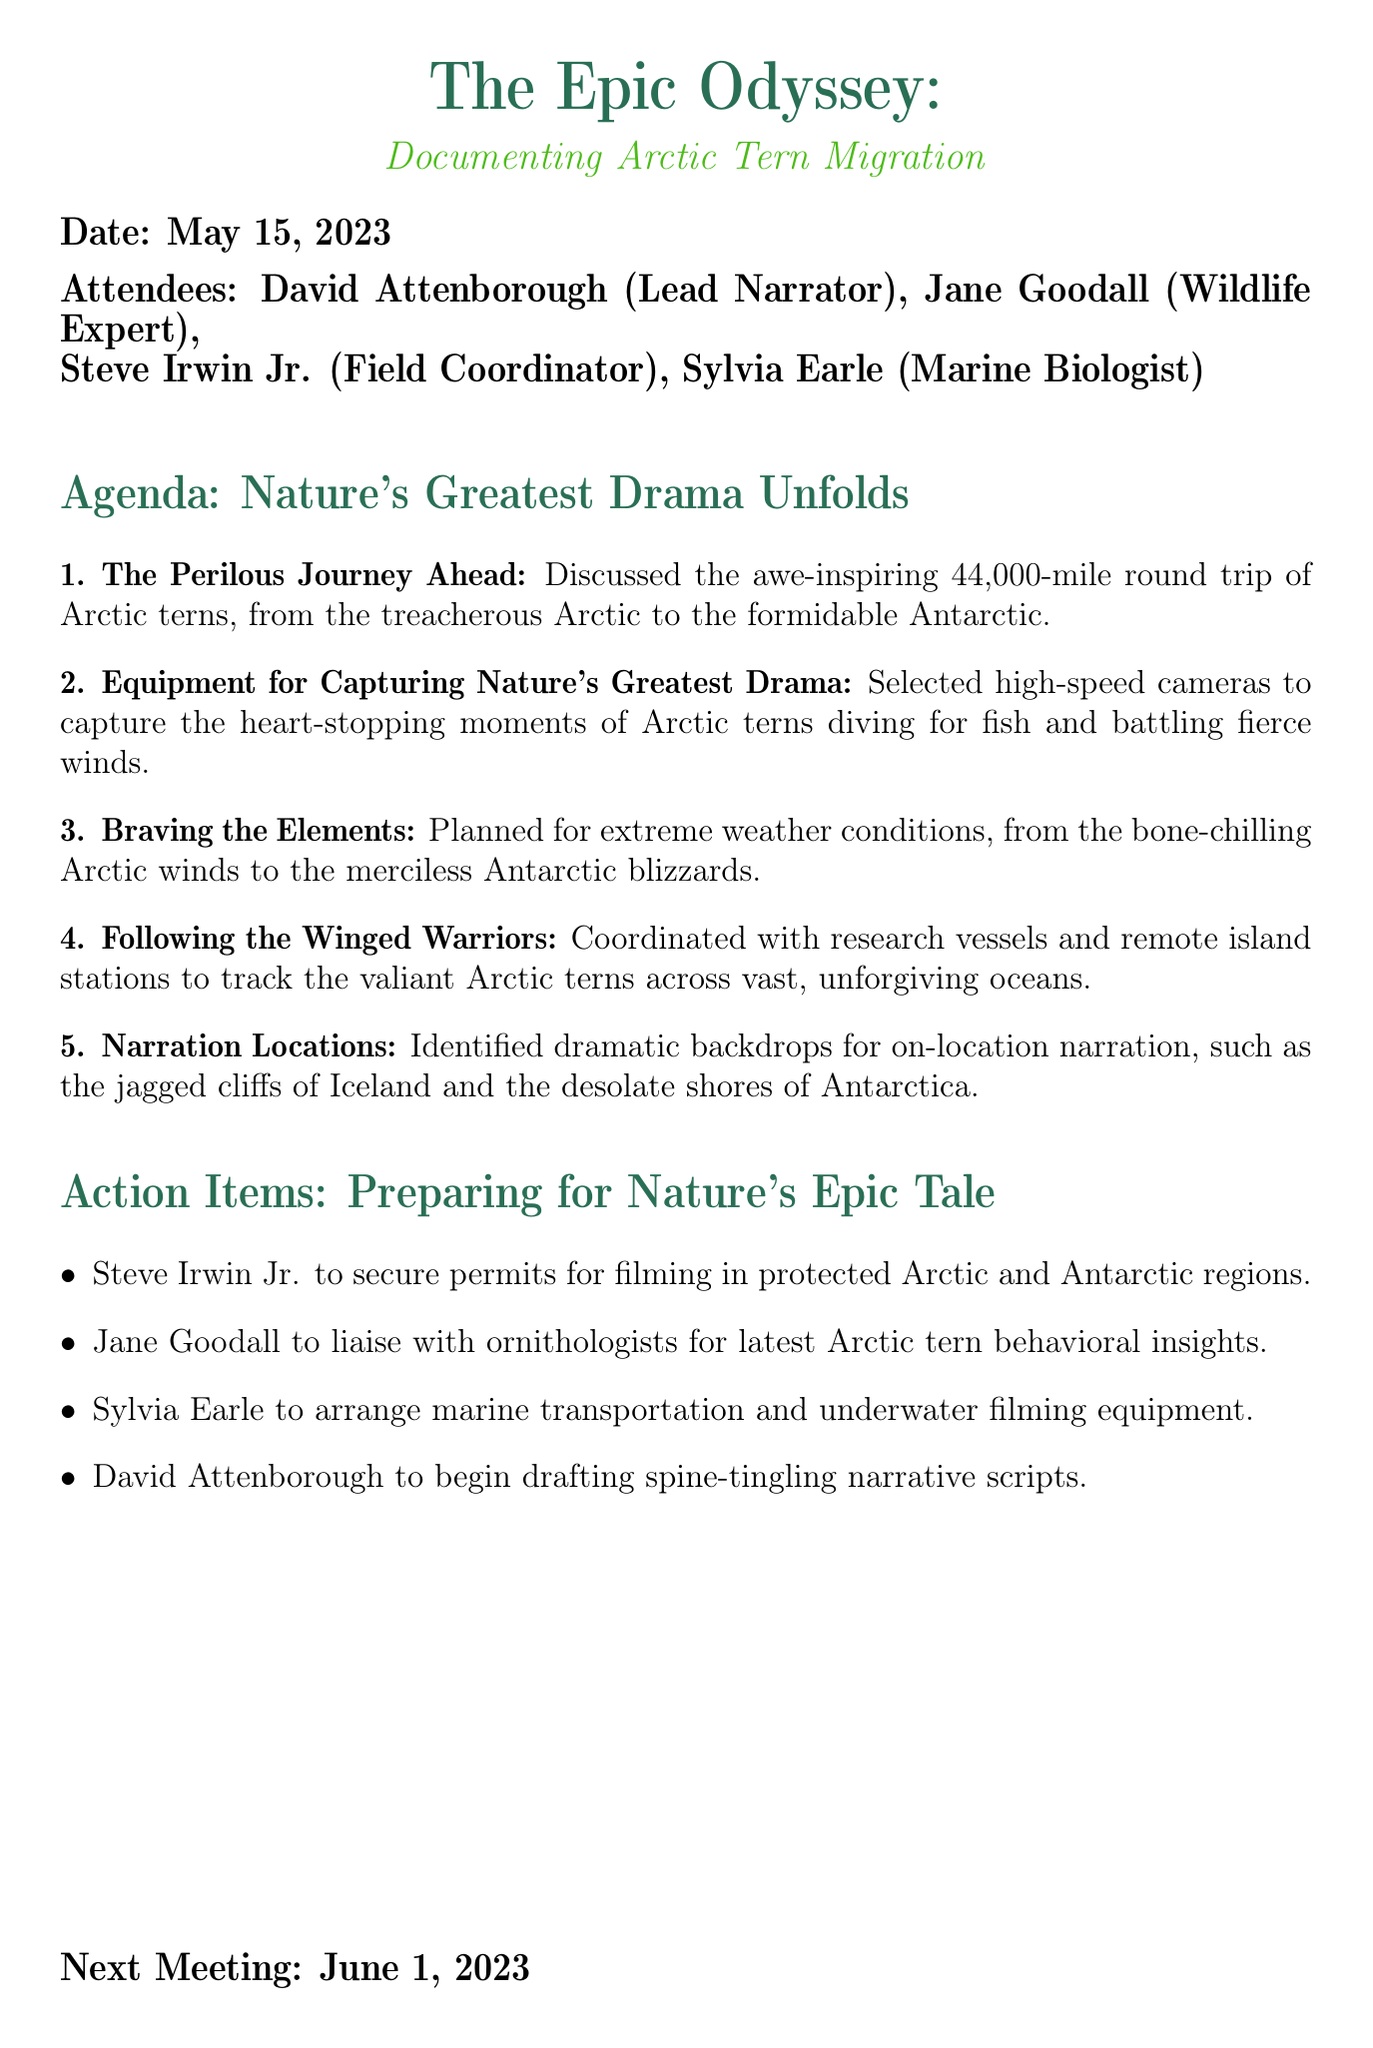What is the meeting title? The meeting title is stated prominently at the beginning of the document.
Answer: The Epic Odyssey: Documenting Arctic Tern Migration Who is the lead narrator? The document lists the attendees, indicating their roles, including the lead narrator.
Answer: David Attenborough What date was the meeting held? The date is clearly mentioned in the meeting information section.
Answer: May 15, 2023 How many agenda items are listed? The number of agenda items can be counted directly from the list in the document.
Answer: Five What is the action item assigned to Sylvia Earle? The action items detail specific tasks assigned to each attendee.
Answer: Arrange marine transportation and underwater filming equipment What extreme conditions are mentioned for planning? The document lists various extreme weather conditions that need to be considered for the expedition.
Answer: Bone-chilling Arctic winds and merciless Antarctic blizzards Which two locations were identified for narration? The document specifically mentions destinations chosen for their dramatic backdrops for narration.
Answer: Jagged cliffs of Iceland and desolate shores of Antarctica When is the next meeting scheduled? The next meeting is specified at the end of the document.
Answer: June 1, 2023 